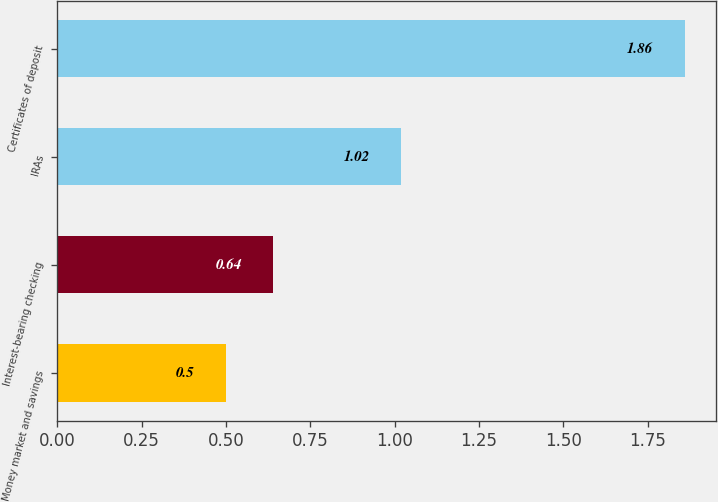Convert chart to OTSL. <chart><loc_0><loc_0><loc_500><loc_500><bar_chart><fcel>Money market and savings<fcel>Interest-bearing checking<fcel>IRAs<fcel>Certificates of deposit<nl><fcel>0.5<fcel>0.64<fcel>1.02<fcel>1.86<nl></chart> 